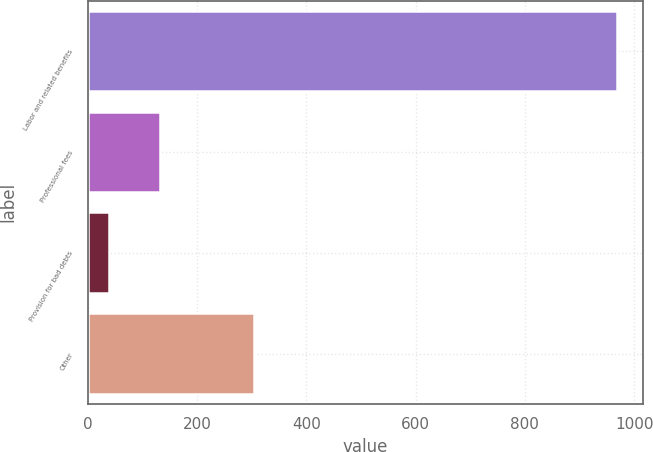Convert chart to OTSL. <chart><loc_0><loc_0><loc_500><loc_500><bar_chart><fcel>Labor and related benefits<fcel>Professional fees<fcel>Provision for bad debts<fcel>Other<nl><fcel>968<fcel>132.8<fcel>40<fcel>305<nl></chart> 